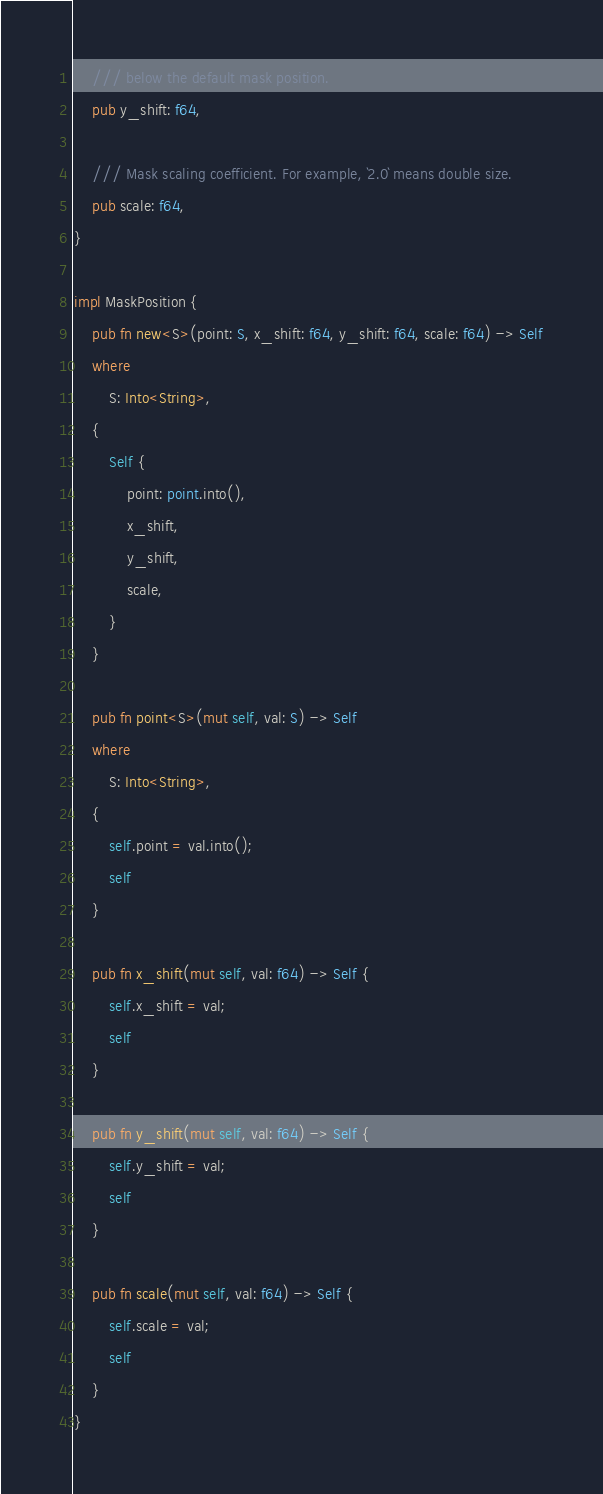Convert code to text. <code><loc_0><loc_0><loc_500><loc_500><_Rust_>    /// below the default mask position.
    pub y_shift: f64,

    /// Mask scaling coefficient. For example, `2.0` means double size.
    pub scale: f64,
}

impl MaskPosition {
    pub fn new<S>(point: S, x_shift: f64, y_shift: f64, scale: f64) -> Self
    where
        S: Into<String>,
    {
        Self {
            point: point.into(),
            x_shift,
            y_shift,
            scale,
        }
    }

    pub fn point<S>(mut self, val: S) -> Self
    where
        S: Into<String>,
    {
        self.point = val.into();
        self
    }

    pub fn x_shift(mut self, val: f64) -> Self {
        self.x_shift = val;
        self
    }

    pub fn y_shift(mut self, val: f64) -> Self {
        self.y_shift = val;
        self
    }

    pub fn scale(mut self, val: f64) -> Self {
        self.scale = val;
        self
    }
}
</code> 